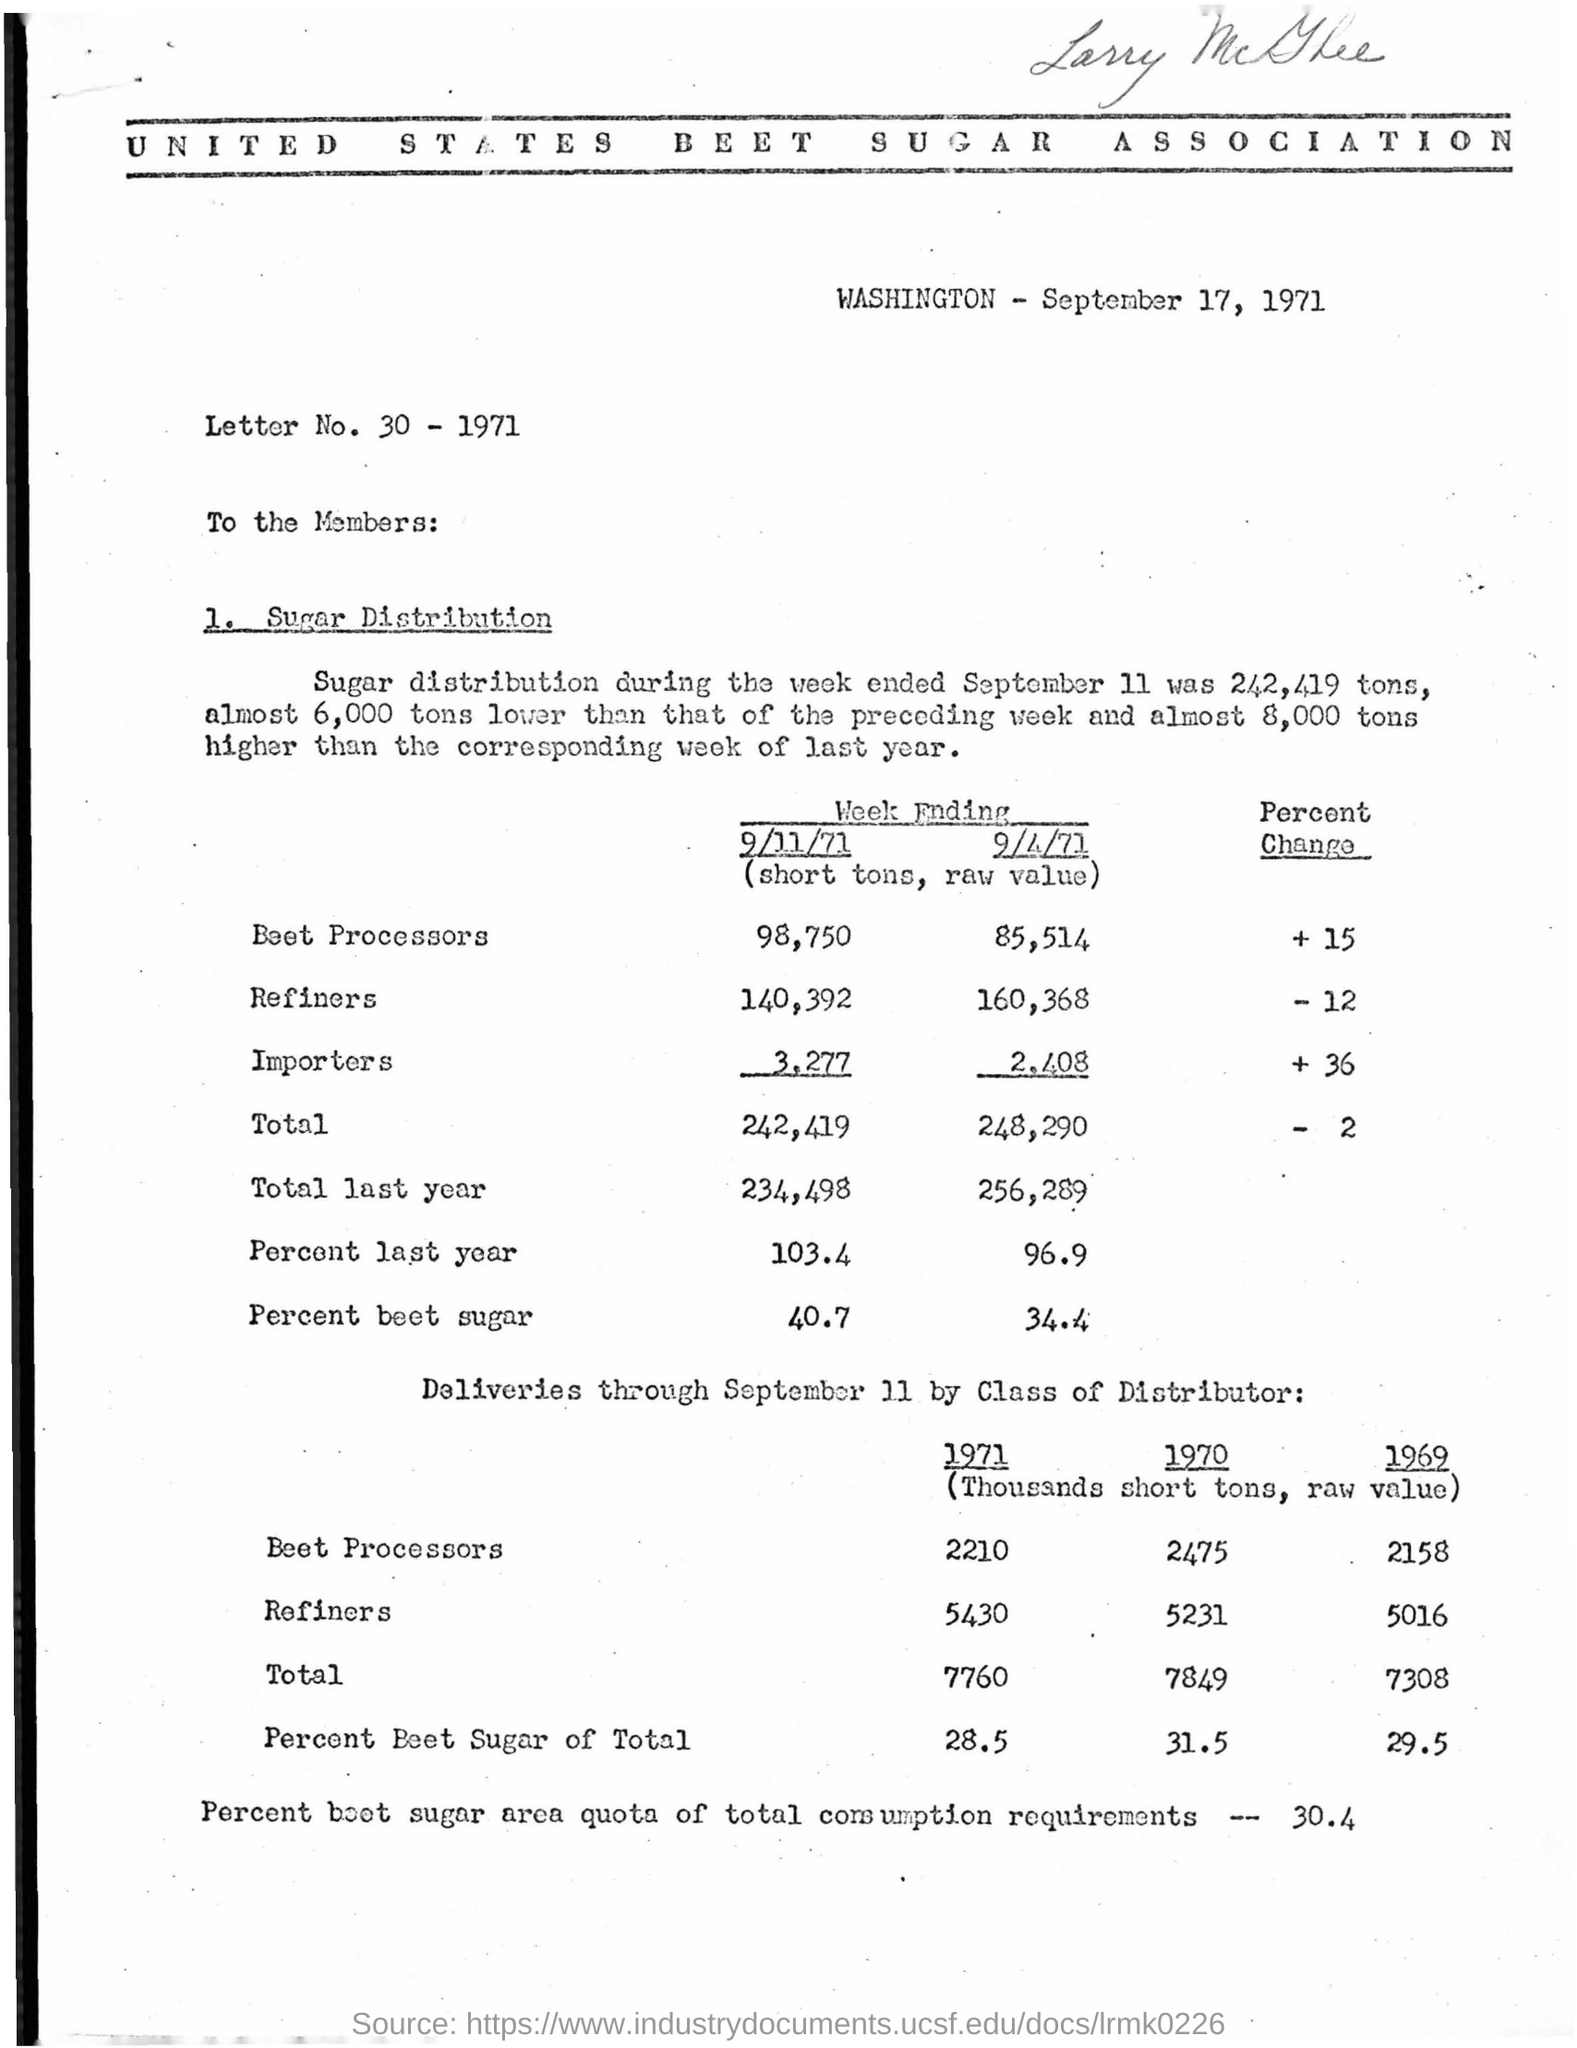Can you tell me the main topic of the document? The document primarily discusses the distribution of sugar for a specific week in September 1971, highlighting the quantities distributed by beet processors, refiners, and importers, and comparing these figures to those of the previous year. What significant data points can be extracted from the information given? Significant data points include the total sugar distribution, which totaled 242,419 short tons for the week ending September 11, 1971; a comparison to the previous year, showing a slight decrease; and the percentage of beet sugar in the total distribution, which was 40.7 percent. 